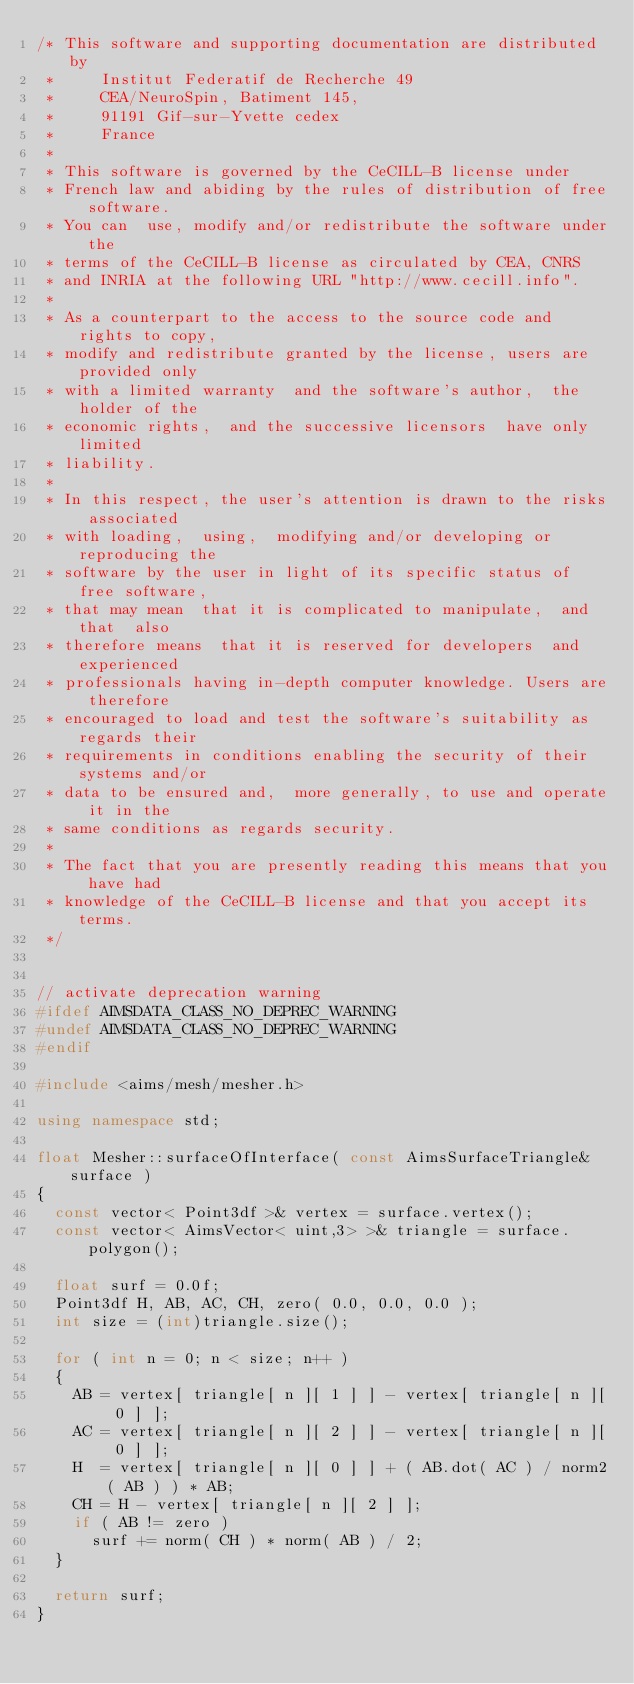<code> <loc_0><loc_0><loc_500><loc_500><_C++_>/* This software and supporting documentation are distributed by
 *     Institut Federatif de Recherche 49
 *     CEA/NeuroSpin, Batiment 145,
 *     91191 Gif-sur-Yvette cedex
 *     France
 *
 * This software is governed by the CeCILL-B license under
 * French law and abiding by the rules of distribution of free software.
 * You can  use, modify and/or redistribute the software under the
 * terms of the CeCILL-B license as circulated by CEA, CNRS
 * and INRIA at the following URL "http://www.cecill.info".
 *
 * As a counterpart to the access to the source code and  rights to copy,
 * modify and redistribute granted by the license, users are provided only
 * with a limited warranty  and the software's author,  the holder of the
 * economic rights,  and the successive licensors  have only  limited
 * liability.
 *
 * In this respect, the user's attention is drawn to the risks associated
 * with loading,  using,  modifying and/or developing or reproducing the
 * software by the user in light of its specific status of free software,
 * that may mean  that it is complicated to manipulate,  and  that  also
 * therefore means  that it is reserved for developers  and  experienced
 * professionals having in-depth computer knowledge. Users are therefore
 * encouraged to load and test the software's suitability as regards their
 * requirements in conditions enabling the security of their systems and/or
 * data to be ensured and,  more generally, to use and operate it in the
 * same conditions as regards security.
 *
 * The fact that you are presently reading this means that you have had
 * knowledge of the CeCILL-B license and that you accept its terms.
 */


// activate deprecation warning
#ifdef AIMSDATA_CLASS_NO_DEPREC_WARNING
#undef AIMSDATA_CLASS_NO_DEPREC_WARNING
#endif

#include <aims/mesh/mesher.h>

using namespace std;

float Mesher::surfaceOfInterface( const AimsSurfaceTriangle& surface )
{
  const vector< Point3df >& vertex = surface.vertex();
  const vector< AimsVector< uint,3> >& triangle = surface.polygon();

  float surf = 0.0f;
  Point3df H, AB, AC, CH, zero( 0.0, 0.0, 0.0 );
  int size = (int)triangle.size();

  for ( int n = 0; n < size; n++ )
  {
    AB = vertex[ triangle[ n ][ 1 ] ] - vertex[ triangle[ n ][ 0 ] ];
    AC = vertex[ triangle[ n ][ 2 ] ] - vertex[ triangle[ n ][ 0 ] ];
    H  = vertex[ triangle[ n ][ 0 ] ] + ( AB.dot( AC ) / norm2( AB ) ) * AB;
    CH = H - vertex[ triangle[ n ][ 2 ] ];
    if ( AB != zero )
      surf += norm( CH ) * norm( AB ) / 2;
  }

  return surf;
}
</code> 